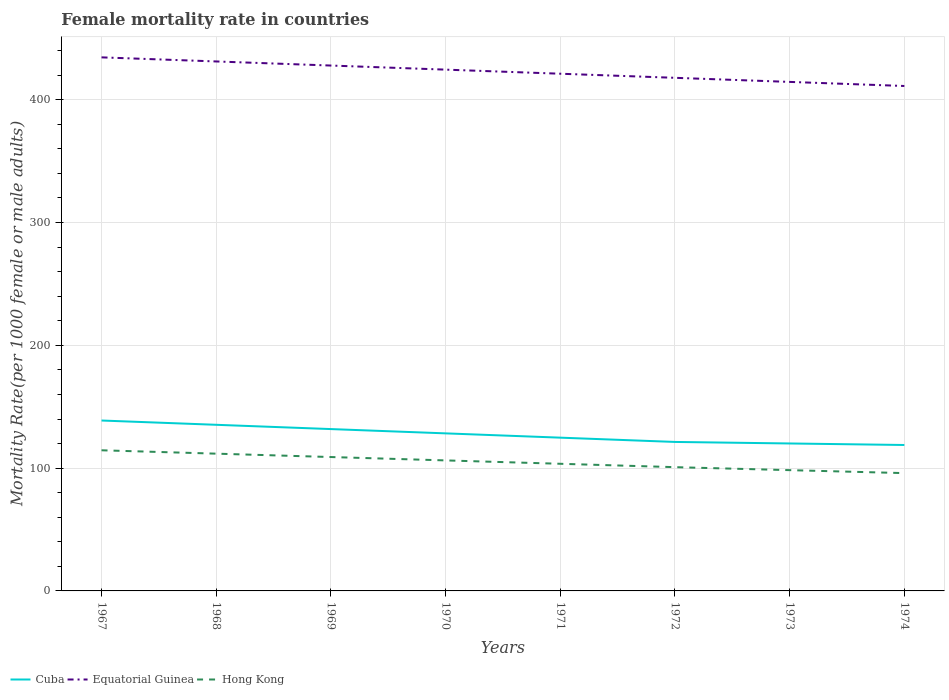Does the line corresponding to Equatorial Guinea intersect with the line corresponding to Hong Kong?
Ensure brevity in your answer.  No. Is the number of lines equal to the number of legend labels?
Provide a short and direct response. Yes. Across all years, what is the maximum female mortality rate in Hong Kong?
Ensure brevity in your answer.  95.92. In which year was the female mortality rate in Cuba maximum?
Ensure brevity in your answer.  1974. What is the total female mortality rate in Cuba in the graph?
Offer a very short reply. 1.24. What is the difference between the highest and the second highest female mortality rate in Hong Kong?
Provide a succinct answer. 18.6. Is the female mortality rate in Cuba strictly greater than the female mortality rate in Equatorial Guinea over the years?
Provide a succinct answer. Yes. How many lines are there?
Offer a very short reply. 3. How many years are there in the graph?
Offer a very short reply. 8. Does the graph contain any zero values?
Your response must be concise. No. Does the graph contain grids?
Make the answer very short. Yes. How many legend labels are there?
Keep it short and to the point. 3. How are the legend labels stacked?
Give a very brief answer. Horizontal. What is the title of the graph?
Give a very brief answer. Female mortality rate in countries. What is the label or title of the X-axis?
Your answer should be very brief. Years. What is the label or title of the Y-axis?
Offer a very short reply. Mortality Rate(per 1000 female or male adults). What is the Mortality Rate(per 1000 female or male adults) in Cuba in 1967?
Keep it short and to the point. 138.77. What is the Mortality Rate(per 1000 female or male adults) of Equatorial Guinea in 1967?
Offer a terse response. 434.49. What is the Mortality Rate(per 1000 female or male adults) of Hong Kong in 1967?
Offer a very short reply. 114.52. What is the Mortality Rate(per 1000 female or male adults) in Cuba in 1968?
Keep it short and to the point. 135.28. What is the Mortality Rate(per 1000 female or male adults) in Equatorial Guinea in 1968?
Make the answer very short. 431.16. What is the Mortality Rate(per 1000 female or male adults) of Hong Kong in 1968?
Offer a very short reply. 111.78. What is the Mortality Rate(per 1000 female or male adults) of Cuba in 1969?
Provide a short and direct response. 131.79. What is the Mortality Rate(per 1000 female or male adults) in Equatorial Guinea in 1969?
Your answer should be compact. 427.83. What is the Mortality Rate(per 1000 female or male adults) of Hong Kong in 1969?
Provide a short and direct response. 109.03. What is the Mortality Rate(per 1000 female or male adults) of Cuba in 1970?
Give a very brief answer. 128.3. What is the Mortality Rate(per 1000 female or male adults) of Equatorial Guinea in 1970?
Your answer should be very brief. 424.5. What is the Mortality Rate(per 1000 female or male adults) in Hong Kong in 1970?
Offer a terse response. 106.28. What is the Mortality Rate(per 1000 female or male adults) in Cuba in 1971?
Keep it short and to the point. 124.81. What is the Mortality Rate(per 1000 female or male adults) of Equatorial Guinea in 1971?
Make the answer very short. 421.17. What is the Mortality Rate(per 1000 female or male adults) of Hong Kong in 1971?
Give a very brief answer. 103.53. What is the Mortality Rate(per 1000 female or male adults) in Cuba in 1972?
Your answer should be very brief. 121.32. What is the Mortality Rate(per 1000 female or male adults) of Equatorial Guinea in 1972?
Keep it short and to the point. 417.84. What is the Mortality Rate(per 1000 female or male adults) in Hong Kong in 1972?
Provide a short and direct response. 100.79. What is the Mortality Rate(per 1000 female or male adults) of Cuba in 1973?
Provide a succinct answer. 120.08. What is the Mortality Rate(per 1000 female or male adults) in Equatorial Guinea in 1973?
Provide a short and direct response. 414.51. What is the Mortality Rate(per 1000 female or male adults) in Hong Kong in 1973?
Your response must be concise. 98.36. What is the Mortality Rate(per 1000 female or male adults) of Cuba in 1974?
Ensure brevity in your answer.  118.83. What is the Mortality Rate(per 1000 female or male adults) in Equatorial Guinea in 1974?
Your answer should be compact. 411.18. What is the Mortality Rate(per 1000 female or male adults) in Hong Kong in 1974?
Keep it short and to the point. 95.92. Across all years, what is the maximum Mortality Rate(per 1000 female or male adults) in Cuba?
Your response must be concise. 138.77. Across all years, what is the maximum Mortality Rate(per 1000 female or male adults) of Equatorial Guinea?
Offer a very short reply. 434.49. Across all years, what is the maximum Mortality Rate(per 1000 female or male adults) of Hong Kong?
Provide a succinct answer. 114.52. Across all years, what is the minimum Mortality Rate(per 1000 female or male adults) of Cuba?
Give a very brief answer. 118.83. Across all years, what is the minimum Mortality Rate(per 1000 female or male adults) in Equatorial Guinea?
Keep it short and to the point. 411.18. Across all years, what is the minimum Mortality Rate(per 1000 female or male adults) in Hong Kong?
Your response must be concise. 95.92. What is the total Mortality Rate(per 1000 female or male adults) of Cuba in the graph?
Keep it short and to the point. 1019.19. What is the total Mortality Rate(per 1000 female or male adults) of Equatorial Guinea in the graph?
Give a very brief answer. 3382.68. What is the total Mortality Rate(per 1000 female or male adults) of Hong Kong in the graph?
Your answer should be very brief. 840.21. What is the difference between the Mortality Rate(per 1000 female or male adults) in Cuba in 1967 and that in 1968?
Your response must be concise. 3.49. What is the difference between the Mortality Rate(per 1000 female or male adults) of Equatorial Guinea in 1967 and that in 1968?
Your answer should be very brief. 3.33. What is the difference between the Mortality Rate(per 1000 female or male adults) in Hong Kong in 1967 and that in 1968?
Offer a very short reply. 2.75. What is the difference between the Mortality Rate(per 1000 female or male adults) in Cuba in 1967 and that in 1969?
Provide a short and direct response. 6.98. What is the difference between the Mortality Rate(per 1000 female or male adults) of Equatorial Guinea in 1967 and that in 1969?
Offer a terse response. 6.66. What is the difference between the Mortality Rate(per 1000 female or male adults) in Hong Kong in 1967 and that in 1969?
Keep it short and to the point. 5.49. What is the difference between the Mortality Rate(per 1000 female or male adults) in Cuba in 1967 and that in 1970?
Ensure brevity in your answer.  10.47. What is the difference between the Mortality Rate(per 1000 female or male adults) in Equatorial Guinea in 1967 and that in 1970?
Your answer should be compact. 9.99. What is the difference between the Mortality Rate(per 1000 female or male adults) in Hong Kong in 1967 and that in 1970?
Make the answer very short. 8.24. What is the difference between the Mortality Rate(per 1000 female or male adults) of Cuba in 1967 and that in 1971?
Offer a terse response. 13.96. What is the difference between the Mortality Rate(per 1000 female or male adults) in Equatorial Guinea in 1967 and that in 1971?
Your answer should be very brief. 13.32. What is the difference between the Mortality Rate(per 1000 female or male adults) of Hong Kong in 1967 and that in 1971?
Your answer should be very brief. 10.99. What is the difference between the Mortality Rate(per 1000 female or male adults) of Cuba in 1967 and that in 1972?
Offer a terse response. 17.45. What is the difference between the Mortality Rate(per 1000 female or male adults) of Equatorial Guinea in 1967 and that in 1972?
Make the answer very short. 16.65. What is the difference between the Mortality Rate(per 1000 female or male adults) of Hong Kong in 1967 and that in 1972?
Ensure brevity in your answer.  13.74. What is the difference between the Mortality Rate(per 1000 female or male adults) of Cuba in 1967 and that in 1973?
Keep it short and to the point. 18.69. What is the difference between the Mortality Rate(per 1000 female or male adults) of Equatorial Guinea in 1967 and that in 1973?
Your answer should be very brief. 19.98. What is the difference between the Mortality Rate(per 1000 female or male adults) in Hong Kong in 1967 and that in 1973?
Ensure brevity in your answer.  16.17. What is the difference between the Mortality Rate(per 1000 female or male adults) of Cuba in 1967 and that in 1974?
Offer a terse response. 19.94. What is the difference between the Mortality Rate(per 1000 female or male adults) in Equatorial Guinea in 1967 and that in 1974?
Your answer should be very brief. 23.31. What is the difference between the Mortality Rate(per 1000 female or male adults) in Hong Kong in 1967 and that in 1974?
Your answer should be compact. 18.6. What is the difference between the Mortality Rate(per 1000 female or male adults) in Cuba in 1968 and that in 1969?
Provide a short and direct response. 3.49. What is the difference between the Mortality Rate(per 1000 female or male adults) in Equatorial Guinea in 1968 and that in 1969?
Keep it short and to the point. 3.33. What is the difference between the Mortality Rate(per 1000 female or male adults) in Hong Kong in 1968 and that in 1969?
Make the answer very short. 2.75. What is the difference between the Mortality Rate(per 1000 female or male adults) of Cuba in 1968 and that in 1970?
Provide a succinct answer. 6.98. What is the difference between the Mortality Rate(per 1000 female or male adults) in Equatorial Guinea in 1968 and that in 1970?
Give a very brief answer. 6.66. What is the difference between the Mortality Rate(per 1000 female or male adults) in Hong Kong in 1968 and that in 1970?
Provide a short and direct response. 5.49. What is the difference between the Mortality Rate(per 1000 female or male adults) in Cuba in 1968 and that in 1971?
Your response must be concise. 10.47. What is the difference between the Mortality Rate(per 1000 female or male adults) of Equatorial Guinea in 1968 and that in 1971?
Keep it short and to the point. 9.99. What is the difference between the Mortality Rate(per 1000 female or male adults) in Hong Kong in 1968 and that in 1971?
Ensure brevity in your answer.  8.24. What is the difference between the Mortality Rate(per 1000 female or male adults) of Cuba in 1968 and that in 1972?
Your response must be concise. 13.96. What is the difference between the Mortality Rate(per 1000 female or male adults) in Equatorial Guinea in 1968 and that in 1972?
Provide a short and direct response. 13.32. What is the difference between the Mortality Rate(per 1000 female or male adults) of Hong Kong in 1968 and that in 1972?
Offer a very short reply. 10.99. What is the difference between the Mortality Rate(per 1000 female or male adults) of Cuba in 1968 and that in 1973?
Give a very brief answer. 15.2. What is the difference between the Mortality Rate(per 1000 female or male adults) in Equatorial Guinea in 1968 and that in 1973?
Your answer should be very brief. 16.65. What is the difference between the Mortality Rate(per 1000 female or male adults) of Hong Kong in 1968 and that in 1973?
Your answer should be very brief. 13.42. What is the difference between the Mortality Rate(per 1000 female or male adults) of Cuba in 1968 and that in 1974?
Provide a succinct answer. 16.45. What is the difference between the Mortality Rate(per 1000 female or male adults) of Equatorial Guinea in 1968 and that in 1974?
Offer a very short reply. 19.98. What is the difference between the Mortality Rate(per 1000 female or male adults) of Hong Kong in 1968 and that in 1974?
Provide a succinct answer. 15.85. What is the difference between the Mortality Rate(per 1000 female or male adults) in Cuba in 1969 and that in 1970?
Ensure brevity in your answer.  3.49. What is the difference between the Mortality Rate(per 1000 female or male adults) of Equatorial Guinea in 1969 and that in 1970?
Provide a succinct answer. 3.33. What is the difference between the Mortality Rate(per 1000 female or male adults) in Hong Kong in 1969 and that in 1970?
Make the answer very short. 2.75. What is the difference between the Mortality Rate(per 1000 female or male adults) of Cuba in 1969 and that in 1971?
Offer a terse response. 6.98. What is the difference between the Mortality Rate(per 1000 female or male adults) in Equatorial Guinea in 1969 and that in 1971?
Your response must be concise. 6.66. What is the difference between the Mortality Rate(per 1000 female or male adults) in Hong Kong in 1969 and that in 1971?
Your response must be concise. 5.49. What is the difference between the Mortality Rate(per 1000 female or male adults) in Cuba in 1969 and that in 1972?
Keep it short and to the point. 10.47. What is the difference between the Mortality Rate(per 1000 female or male adults) of Equatorial Guinea in 1969 and that in 1972?
Provide a short and direct response. 9.99. What is the difference between the Mortality Rate(per 1000 female or male adults) of Hong Kong in 1969 and that in 1972?
Give a very brief answer. 8.24. What is the difference between the Mortality Rate(per 1000 female or male adults) of Cuba in 1969 and that in 1973?
Your response must be concise. 11.71. What is the difference between the Mortality Rate(per 1000 female or male adults) in Equatorial Guinea in 1969 and that in 1973?
Keep it short and to the point. 13.32. What is the difference between the Mortality Rate(per 1000 female or male adults) of Hong Kong in 1969 and that in 1973?
Make the answer very short. 10.67. What is the difference between the Mortality Rate(per 1000 female or male adults) of Cuba in 1969 and that in 1974?
Make the answer very short. 12.96. What is the difference between the Mortality Rate(per 1000 female or male adults) in Equatorial Guinea in 1969 and that in 1974?
Your response must be concise. 16.65. What is the difference between the Mortality Rate(per 1000 female or male adults) of Hong Kong in 1969 and that in 1974?
Provide a short and direct response. 13.1. What is the difference between the Mortality Rate(per 1000 female or male adults) of Cuba in 1970 and that in 1971?
Provide a succinct answer. 3.49. What is the difference between the Mortality Rate(per 1000 female or male adults) of Equatorial Guinea in 1970 and that in 1971?
Your answer should be very brief. 3.33. What is the difference between the Mortality Rate(per 1000 female or male adults) of Hong Kong in 1970 and that in 1971?
Ensure brevity in your answer.  2.75. What is the difference between the Mortality Rate(per 1000 female or male adults) in Cuba in 1970 and that in 1972?
Offer a very short reply. 6.98. What is the difference between the Mortality Rate(per 1000 female or male adults) in Equatorial Guinea in 1970 and that in 1972?
Ensure brevity in your answer.  6.66. What is the difference between the Mortality Rate(per 1000 female or male adults) in Hong Kong in 1970 and that in 1972?
Provide a short and direct response. 5.49. What is the difference between the Mortality Rate(per 1000 female or male adults) in Cuba in 1970 and that in 1973?
Keep it short and to the point. 8.22. What is the difference between the Mortality Rate(per 1000 female or male adults) in Equatorial Guinea in 1970 and that in 1973?
Keep it short and to the point. 9.99. What is the difference between the Mortality Rate(per 1000 female or male adults) in Hong Kong in 1970 and that in 1973?
Your answer should be compact. 7.93. What is the difference between the Mortality Rate(per 1000 female or male adults) in Cuba in 1970 and that in 1974?
Your answer should be compact. 9.47. What is the difference between the Mortality Rate(per 1000 female or male adults) of Equatorial Guinea in 1970 and that in 1974?
Make the answer very short. 13.32. What is the difference between the Mortality Rate(per 1000 female or male adults) in Hong Kong in 1970 and that in 1974?
Keep it short and to the point. 10.36. What is the difference between the Mortality Rate(per 1000 female or male adults) in Cuba in 1971 and that in 1972?
Offer a terse response. 3.49. What is the difference between the Mortality Rate(per 1000 female or male adults) of Equatorial Guinea in 1971 and that in 1972?
Keep it short and to the point. 3.33. What is the difference between the Mortality Rate(per 1000 female or male adults) of Hong Kong in 1971 and that in 1972?
Ensure brevity in your answer.  2.75. What is the difference between the Mortality Rate(per 1000 female or male adults) in Cuba in 1971 and that in 1973?
Make the answer very short. 4.73. What is the difference between the Mortality Rate(per 1000 female or male adults) of Equatorial Guinea in 1971 and that in 1973?
Offer a terse response. 6.66. What is the difference between the Mortality Rate(per 1000 female or male adults) in Hong Kong in 1971 and that in 1973?
Provide a succinct answer. 5.18. What is the difference between the Mortality Rate(per 1000 female or male adults) in Cuba in 1971 and that in 1974?
Ensure brevity in your answer.  5.98. What is the difference between the Mortality Rate(per 1000 female or male adults) of Equatorial Guinea in 1971 and that in 1974?
Offer a terse response. 9.99. What is the difference between the Mortality Rate(per 1000 female or male adults) in Hong Kong in 1971 and that in 1974?
Provide a succinct answer. 7.61. What is the difference between the Mortality Rate(per 1000 female or male adults) in Cuba in 1972 and that in 1973?
Provide a short and direct response. 1.24. What is the difference between the Mortality Rate(per 1000 female or male adults) of Equatorial Guinea in 1972 and that in 1973?
Provide a short and direct response. 3.33. What is the difference between the Mortality Rate(per 1000 female or male adults) of Hong Kong in 1972 and that in 1973?
Offer a very short reply. 2.43. What is the difference between the Mortality Rate(per 1000 female or male adults) of Cuba in 1972 and that in 1974?
Keep it short and to the point. 2.49. What is the difference between the Mortality Rate(per 1000 female or male adults) in Equatorial Guinea in 1972 and that in 1974?
Offer a terse response. 6.66. What is the difference between the Mortality Rate(per 1000 female or male adults) of Hong Kong in 1972 and that in 1974?
Make the answer very short. 4.86. What is the difference between the Mortality Rate(per 1000 female or male adults) in Cuba in 1973 and that in 1974?
Your answer should be very brief. 1.24. What is the difference between the Mortality Rate(per 1000 female or male adults) of Equatorial Guinea in 1973 and that in 1974?
Ensure brevity in your answer.  3.33. What is the difference between the Mortality Rate(per 1000 female or male adults) in Hong Kong in 1973 and that in 1974?
Ensure brevity in your answer.  2.43. What is the difference between the Mortality Rate(per 1000 female or male adults) in Cuba in 1967 and the Mortality Rate(per 1000 female or male adults) in Equatorial Guinea in 1968?
Offer a terse response. -292.39. What is the difference between the Mortality Rate(per 1000 female or male adults) of Cuba in 1967 and the Mortality Rate(per 1000 female or male adults) of Hong Kong in 1968?
Ensure brevity in your answer.  26.99. What is the difference between the Mortality Rate(per 1000 female or male adults) in Equatorial Guinea in 1967 and the Mortality Rate(per 1000 female or male adults) in Hong Kong in 1968?
Ensure brevity in your answer.  322.72. What is the difference between the Mortality Rate(per 1000 female or male adults) in Cuba in 1967 and the Mortality Rate(per 1000 female or male adults) in Equatorial Guinea in 1969?
Provide a short and direct response. -289.06. What is the difference between the Mortality Rate(per 1000 female or male adults) of Cuba in 1967 and the Mortality Rate(per 1000 female or male adults) of Hong Kong in 1969?
Ensure brevity in your answer.  29.74. What is the difference between the Mortality Rate(per 1000 female or male adults) in Equatorial Guinea in 1967 and the Mortality Rate(per 1000 female or male adults) in Hong Kong in 1969?
Your answer should be very brief. 325.46. What is the difference between the Mortality Rate(per 1000 female or male adults) of Cuba in 1967 and the Mortality Rate(per 1000 female or male adults) of Equatorial Guinea in 1970?
Ensure brevity in your answer.  -285.73. What is the difference between the Mortality Rate(per 1000 female or male adults) in Cuba in 1967 and the Mortality Rate(per 1000 female or male adults) in Hong Kong in 1970?
Offer a terse response. 32.49. What is the difference between the Mortality Rate(per 1000 female or male adults) in Equatorial Guinea in 1967 and the Mortality Rate(per 1000 female or male adults) in Hong Kong in 1970?
Offer a terse response. 328.21. What is the difference between the Mortality Rate(per 1000 female or male adults) of Cuba in 1967 and the Mortality Rate(per 1000 female or male adults) of Equatorial Guinea in 1971?
Your answer should be compact. -282.4. What is the difference between the Mortality Rate(per 1000 female or male adults) in Cuba in 1967 and the Mortality Rate(per 1000 female or male adults) in Hong Kong in 1971?
Give a very brief answer. 35.24. What is the difference between the Mortality Rate(per 1000 female or male adults) of Equatorial Guinea in 1967 and the Mortality Rate(per 1000 female or male adults) of Hong Kong in 1971?
Provide a short and direct response. 330.96. What is the difference between the Mortality Rate(per 1000 female or male adults) of Cuba in 1967 and the Mortality Rate(per 1000 female or male adults) of Equatorial Guinea in 1972?
Provide a short and direct response. -279.07. What is the difference between the Mortality Rate(per 1000 female or male adults) in Cuba in 1967 and the Mortality Rate(per 1000 female or male adults) in Hong Kong in 1972?
Your answer should be compact. 37.98. What is the difference between the Mortality Rate(per 1000 female or male adults) of Equatorial Guinea in 1967 and the Mortality Rate(per 1000 female or male adults) of Hong Kong in 1972?
Keep it short and to the point. 333.7. What is the difference between the Mortality Rate(per 1000 female or male adults) of Cuba in 1967 and the Mortality Rate(per 1000 female or male adults) of Equatorial Guinea in 1973?
Offer a very short reply. -275.74. What is the difference between the Mortality Rate(per 1000 female or male adults) of Cuba in 1967 and the Mortality Rate(per 1000 female or male adults) of Hong Kong in 1973?
Your answer should be compact. 40.41. What is the difference between the Mortality Rate(per 1000 female or male adults) in Equatorial Guinea in 1967 and the Mortality Rate(per 1000 female or male adults) in Hong Kong in 1973?
Offer a terse response. 336.13. What is the difference between the Mortality Rate(per 1000 female or male adults) of Cuba in 1967 and the Mortality Rate(per 1000 female or male adults) of Equatorial Guinea in 1974?
Offer a very short reply. -272.41. What is the difference between the Mortality Rate(per 1000 female or male adults) of Cuba in 1967 and the Mortality Rate(per 1000 female or male adults) of Hong Kong in 1974?
Your response must be concise. 42.84. What is the difference between the Mortality Rate(per 1000 female or male adults) in Equatorial Guinea in 1967 and the Mortality Rate(per 1000 female or male adults) in Hong Kong in 1974?
Your answer should be very brief. 338.57. What is the difference between the Mortality Rate(per 1000 female or male adults) in Cuba in 1968 and the Mortality Rate(per 1000 female or male adults) in Equatorial Guinea in 1969?
Provide a succinct answer. -292.55. What is the difference between the Mortality Rate(per 1000 female or male adults) of Cuba in 1968 and the Mortality Rate(per 1000 female or male adults) of Hong Kong in 1969?
Your answer should be compact. 26.25. What is the difference between the Mortality Rate(per 1000 female or male adults) of Equatorial Guinea in 1968 and the Mortality Rate(per 1000 female or male adults) of Hong Kong in 1969?
Provide a succinct answer. 322.13. What is the difference between the Mortality Rate(per 1000 female or male adults) in Cuba in 1968 and the Mortality Rate(per 1000 female or male adults) in Equatorial Guinea in 1970?
Your answer should be very brief. -289.22. What is the difference between the Mortality Rate(per 1000 female or male adults) of Cuba in 1968 and the Mortality Rate(per 1000 female or male adults) of Hong Kong in 1970?
Offer a very short reply. 29. What is the difference between the Mortality Rate(per 1000 female or male adults) of Equatorial Guinea in 1968 and the Mortality Rate(per 1000 female or male adults) of Hong Kong in 1970?
Keep it short and to the point. 324.88. What is the difference between the Mortality Rate(per 1000 female or male adults) of Cuba in 1968 and the Mortality Rate(per 1000 female or male adults) of Equatorial Guinea in 1971?
Your answer should be very brief. -285.89. What is the difference between the Mortality Rate(per 1000 female or male adults) of Cuba in 1968 and the Mortality Rate(per 1000 female or male adults) of Hong Kong in 1971?
Your answer should be compact. 31.75. What is the difference between the Mortality Rate(per 1000 female or male adults) in Equatorial Guinea in 1968 and the Mortality Rate(per 1000 female or male adults) in Hong Kong in 1971?
Offer a very short reply. 327.63. What is the difference between the Mortality Rate(per 1000 female or male adults) of Cuba in 1968 and the Mortality Rate(per 1000 female or male adults) of Equatorial Guinea in 1972?
Make the answer very short. -282.56. What is the difference between the Mortality Rate(per 1000 female or male adults) in Cuba in 1968 and the Mortality Rate(per 1000 female or male adults) in Hong Kong in 1972?
Give a very brief answer. 34.49. What is the difference between the Mortality Rate(per 1000 female or male adults) in Equatorial Guinea in 1968 and the Mortality Rate(per 1000 female or male adults) in Hong Kong in 1972?
Your response must be concise. 330.37. What is the difference between the Mortality Rate(per 1000 female or male adults) in Cuba in 1968 and the Mortality Rate(per 1000 female or male adults) in Equatorial Guinea in 1973?
Offer a terse response. -279.23. What is the difference between the Mortality Rate(per 1000 female or male adults) of Cuba in 1968 and the Mortality Rate(per 1000 female or male adults) of Hong Kong in 1973?
Your answer should be very brief. 36.92. What is the difference between the Mortality Rate(per 1000 female or male adults) in Equatorial Guinea in 1968 and the Mortality Rate(per 1000 female or male adults) in Hong Kong in 1973?
Keep it short and to the point. 332.8. What is the difference between the Mortality Rate(per 1000 female or male adults) in Cuba in 1968 and the Mortality Rate(per 1000 female or male adults) in Equatorial Guinea in 1974?
Make the answer very short. -275.9. What is the difference between the Mortality Rate(per 1000 female or male adults) in Cuba in 1968 and the Mortality Rate(per 1000 female or male adults) in Hong Kong in 1974?
Ensure brevity in your answer.  39.36. What is the difference between the Mortality Rate(per 1000 female or male adults) of Equatorial Guinea in 1968 and the Mortality Rate(per 1000 female or male adults) of Hong Kong in 1974?
Give a very brief answer. 335.24. What is the difference between the Mortality Rate(per 1000 female or male adults) of Cuba in 1969 and the Mortality Rate(per 1000 female or male adults) of Equatorial Guinea in 1970?
Offer a terse response. -292.71. What is the difference between the Mortality Rate(per 1000 female or male adults) in Cuba in 1969 and the Mortality Rate(per 1000 female or male adults) in Hong Kong in 1970?
Your answer should be very brief. 25.51. What is the difference between the Mortality Rate(per 1000 female or male adults) of Equatorial Guinea in 1969 and the Mortality Rate(per 1000 female or male adults) of Hong Kong in 1970?
Offer a very short reply. 321.55. What is the difference between the Mortality Rate(per 1000 female or male adults) in Cuba in 1969 and the Mortality Rate(per 1000 female or male adults) in Equatorial Guinea in 1971?
Keep it short and to the point. -289.38. What is the difference between the Mortality Rate(per 1000 female or male adults) in Cuba in 1969 and the Mortality Rate(per 1000 female or male adults) in Hong Kong in 1971?
Offer a terse response. 28.26. What is the difference between the Mortality Rate(per 1000 female or male adults) of Equatorial Guinea in 1969 and the Mortality Rate(per 1000 female or male adults) of Hong Kong in 1971?
Make the answer very short. 324.3. What is the difference between the Mortality Rate(per 1000 female or male adults) of Cuba in 1969 and the Mortality Rate(per 1000 female or male adults) of Equatorial Guinea in 1972?
Provide a succinct answer. -286.05. What is the difference between the Mortality Rate(per 1000 female or male adults) in Cuba in 1969 and the Mortality Rate(per 1000 female or male adults) in Hong Kong in 1972?
Your response must be concise. 31. What is the difference between the Mortality Rate(per 1000 female or male adults) in Equatorial Guinea in 1969 and the Mortality Rate(per 1000 female or male adults) in Hong Kong in 1972?
Your answer should be very brief. 327.04. What is the difference between the Mortality Rate(per 1000 female or male adults) of Cuba in 1969 and the Mortality Rate(per 1000 female or male adults) of Equatorial Guinea in 1973?
Make the answer very short. -282.72. What is the difference between the Mortality Rate(per 1000 female or male adults) in Cuba in 1969 and the Mortality Rate(per 1000 female or male adults) in Hong Kong in 1973?
Ensure brevity in your answer.  33.44. What is the difference between the Mortality Rate(per 1000 female or male adults) in Equatorial Guinea in 1969 and the Mortality Rate(per 1000 female or male adults) in Hong Kong in 1973?
Give a very brief answer. 329.47. What is the difference between the Mortality Rate(per 1000 female or male adults) in Cuba in 1969 and the Mortality Rate(per 1000 female or male adults) in Equatorial Guinea in 1974?
Keep it short and to the point. -279.39. What is the difference between the Mortality Rate(per 1000 female or male adults) in Cuba in 1969 and the Mortality Rate(per 1000 female or male adults) in Hong Kong in 1974?
Keep it short and to the point. 35.87. What is the difference between the Mortality Rate(per 1000 female or male adults) of Equatorial Guinea in 1969 and the Mortality Rate(per 1000 female or male adults) of Hong Kong in 1974?
Provide a short and direct response. 331.9. What is the difference between the Mortality Rate(per 1000 female or male adults) of Cuba in 1970 and the Mortality Rate(per 1000 female or male adults) of Equatorial Guinea in 1971?
Offer a terse response. -292.87. What is the difference between the Mortality Rate(per 1000 female or male adults) in Cuba in 1970 and the Mortality Rate(per 1000 female or male adults) in Hong Kong in 1971?
Your answer should be compact. 24.77. What is the difference between the Mortality Rate(per 1000 female or male adults) of Equatorial Guinea in 1970 and the Mortality Rate(per 1000 female or male adults) of Hong Kong in 1971?
Keep it short and to the point. 320.96. What is the difference between the Mortality Rate(per 1000 female or male adults) in Cuba in 1970 and the Mortality Rate(per 1000 female or male adults) in Equatorial Guinea in 1972?
Your response must be concise. -289.54. What is the difference between the Mortality Rate(per 1000 female or male adults) in Cuba in 1970 and the Mortality Rate(per 1000 female or male adults) in Hong Kong in 1972?
Your answer should be very brief. 27.51. What is the difference between the Mortality Rate(per 1000 female or male adults) of Equatorial Guinea in 1970 and the Mortality Rate(per 1000 female or male adults) of Hong Kong in 1972?
Provide a succinct answer. 323.71. What is the difference between the Mortality Rate(per 1000 female or male adults) of Cuba in 1970 and the Mortality Rate(per 1000 female or male adults) of Equatorial Guinea in 1973?
Ensure brevity in your answer.  -286.21. What is the difference between the Mortality Rate(per 1000 female or male adults) in Cuba in 1970 and the Mortality Rate(per 1000 female or male adults) in Hong Kong in 1973?
Make the answer very short. 29.95. What is the difference between the Mortality Rate(per 1000 female or male adults) in Equatorial Guinea in 1970 and the Mortality Rate(per 1000 female or male adults) in Hong Kong in 1973?
Keep it short and to the point. 326.14. What is the difference between the Mortality Rate(per 1000 female or male adults) of Cuba in 1970 and the Mortality Rate(per 1000 female or male adults) of Equatorial Guinea in 1974?
Your answer should be very brief. -282.88. What is the difference between the Mortality Rate(per 1000 female or male adults) in Cuba in 1970 and the Mortality Rate(per 1000 female or male adults) in Hong Kong in 1974?
Your answer should be very brief. 32.38. What is the difference between the Mortality Rate(per 1000 female or male adults) of Equatorial Guinea in 1970 and the Mortality Rate(per 1000 female or male adults) of Hong Kong in 1974?
Make the answer very short. 328.57. What is the difference between the Mortality Rate(per 1000 female or male adults) in Cuba in 1971 and the Mortality Rate(per 1000 female or male adults) in Equatorial Guinea in 1972?
Offer a very short reply. -293.03. What is the difference between the Mortality Rate(per 1000 female or male adults) in Cuba in 1971 and the Mortality Rate(per 1000 female or male adults) in Hong Kong in 1972?
Provide a succinct answer. 24.02. What is the difference between the Mortality Rate(per 1000 female or male adults) in Equatorial Guinea in 1971 and the Mortality Rate(per 1000 female or male adults) in Hong Kong in 1972?
Keep it short and to the point. 320.38. What is the difference between the Mortality Rate(per 1000 female or male adults) of Cuba in 1971 and the Mortality Rate(per 1000 female or male adults) of Equatorial Guinea in 1973?
Your response must be concise. -289.7. What is the difference between the Mortality Rate(per 1000 female or male adults) in Cuba in 1971 and the Mortality Rate(per 1000 female or male adults) in Hong Kong in 1973?
Your response must be concise. 26.45. What is the difference between the Mortality Rate(per 1000 female or male adults) of Equatorial Guinea in 1971 and the Mortality Rate(per 1000 female or male adults) of Hong Kong in 1973?
Make the answer very short. 322.81. What is the difference between the Mortality Rate(per 1000 female or male adults) in Cuba in 1971 and the Mortality Rate(per 1000 female or male adults) in Equatorial Guinea in 1974?
Your answer should be compact. -286.37. What is the difference between the Mortality Rate(per 1000 female or male adults) in Cuba in 1971 and the Mortality Rate(per 1000 female or male adults) in Hong Kong in 1974?
Offer a very short reply. 28.89. What is the difference between the Mortality Rate(per 1000 female or male adults) in Equatorial Guinea in 1971 and the Mortality Rate(per 1000 female or male adults) in Hong Kong in 1974?
Make the answer very short. 325.24. What is the difference between the Mortality Rate(per 1000 female or male adults) in Cuba in 1972 and the Mortality Rate(per 1000 female or male adults) in Equatorial Guinea in 1973?
Your answer should be compact. -293.19. What is the difference between the Mortality Rate(per 1000 female or male adults) of Cuba in 1972 and the Mortality Rate(per 1000 female or male adults) of Hong Kong in 1973?
Make the answer very short. 22.96. What is the difference between the Mortality Rate(per 1000 female or male adults) in Equatorial Guinea in 1972 and the Mortality Rate(per 1000 female or male adults) in Hong Kong in 1973?
Offer a terse response. 319.48. What is the difference between the Mortality Rate(per 1000 female or male adults) in Cuba in 1972 and the Mortality Rate(per 1000 female or male adults) in Equatorial Guinea in 1974?
Offer a very short reply. -289.86. What is the difference between the Mortality Rate(per 1000 female or male adults) of Cuba in 1972 and the Mortality Rate(per 1000 female or male adults) of Hong Kong in 1974?
Keep it short and to the point. 25.4. What is the difference between the Mortality Rate(per 1000 female or male adults) in Equatorial Guinea in 1972 and the Mortality Rate(per 1000 female or male adults) in Hong Kong in 1974?
Your response must be concise. 321.91. What is the difference between the Mortality Rate(per 1000 female or male adults) of Cuba in 1973 and the Mortality Rate(per 1000 female or male adults) of Equatorial Guinea in 1974?
Keep it short and to the point. -291.1. What is the difference between the Mortality Rate(per 1000 female or male adults) in Cuba in 1973 and the Mortality Rate(per 1000 female or male adults) in Hong Kong in 1974?
Your answer should be compact. 24.15. What is the difference between the Mortality Rate(per 1000 female or male adults) in Equatorial Guinea in 1973 and the Mortality Rate(per 1000 female or male adults) in Hong Kong in 1974?
Provide a short and direct response. 318.58. What is the average Mortality Rate(per 1000 female or male adults) of Cuba per year?
Offer a terse response. 127.4. What is the average Mortality Rate(per 1000 female or male adults) of Equatorial Guinea per year?
Ensure brevity in your answer.  422.83. What is the average Mortality Rate(per 1000 female or male adults) of Hong Kong per year?
Your response must be concise. 105.03. In the year 1967, what is the difference between the Mortality Rate(per 1000 female or male adults) of Cuba and Mortality Rate(per 1000 female or male adults) of Equatorial Guinea?
Ensure brevity in your answer.  -295.72. In the year 1967, what is the difference between the Mortality Rate(per 1000 female or male adults) of Cuba and Mortality Rate(per 1000 female or male adults) of Hong Kong?
Offer a terse response. 24.25. In the year 1967, what is the difference between the Mortality Rate(per 1000 female or male adults) in Equatorial Guinea and Mortality Rate(per 1000 female or male adults) in Hong Kong?
Ensure brevity in your answer.  319.97. In the year 1968, what is the difference between the Mortality Rate(per 1000 female or male adults) in Cuba and Mortality Rate(per 1000 female or male adults) in Equatorial Guinea?
Provide a succinct answer. -295.88. In the year 1968, what is the difference between the Mortality Rate(per 1000 female or male adults) in Cuba and Mortality Rate(per 1000 female or male adults) in Hong Kong?
Make the answer very short. 23.51. In the year 1968, what is the difference between the Mortality Rate(per 1000 female or male adults) of Equatorial Guinea and Mortality Rate(per 1000 female or male adults) of Hong Kong?
Ensure brevity in your answer.  319.38. In the year 1969, what is the difference between the Mortality Rate(per 1000 female or male adults) of Cuba and Mortality Rate(per 1000 female or male adults) of Equatorial Guinea?
Your answer should be compact. -296.04. In the year 1969, what is the difference between the Mortality Rate(per 1000 female or male adults) in Cuba and Mortality Rate(per 1000 female or male adults) in Hong Kong?
Your answer should be compact. 22.76. In the year 1969, what is the difference between the Mortality Rate(per 1000 female or male adults) in Equatorial Guinea and Mortality Rate(per 1000 female or male adults) in Hong Kong?
Give a very brief answer. 318.8. In the year 1970, what is the difference between the Mortality Rate(per 1000 female or male adults) in Cuba and Mortality Rate(per 1000 female or male adults) in Equatorial Guinea?
Make the answer very short. -296.2. In the year 1970, what is the difference between the Mortality Rate(per 1000 female or male adults) of Cuba and Mortality Rate(per 1000 female or male adults) of Hong Kong?
Keep it short and to the point. 22.02. In the year 1970, what is the difference between the Mortality Rate(per 1000 female or male adults) of Equatorial Guinea and Mortality Rate(per 1000 female or male adults) of Hong Kong?
Your answer should be very brief. 318.22. In the year 1971, what is the difference between the Mortality Rate(per 1000 female or male adults) in Cuba and Mortality Rate(per 1000 female or male adults) in Equatorial Guinea?
Provide a short and direct response. -296.36. In the year 1971, what is the difference between the Mortality Rate(per 1000 female or male adults) in Cuba and Mortality Rate(per 1000 female or male adults) in Hong Kong?
Your answer should be compact. 21.28. In the year 1971, what is the difference between the Mortality Rate(per 1000 female or male adults) in Equatorial Guinea and Mortality Rate(per 1000 female or male adults) in Hong Kong?
Offer a very short reply. 317.63. In the year 1972, what is the difference between the Mortality Rate(per 1000 female or male adults) in Cuba and Mortality Rate(per 1000 female or male adults) in Equatorial Guinea?
Make the answer very short. -296.52. In the year 1972, what is the difference between the Mortality Rate(per 1000 female or male adults) of Cuba and Mortality Rate(per 1000 female or male adults) of Hong Kong?
Offer a terse response. 20.53. In the year 1972, what is the difference between the Mortality Rate(per 1000 female or male adults) in Equatorial Guinea and Mortality Rate(per 1000 female or male adults) in Hong Kong?
Ensure brevity in your answer.  317.05. In the year 1973, what is the difference between the Mortality Rate(per 1000 female or male adults) of Cuba and Mortality Rate(per 1000 female or male adults) of Equatorial Guinea?
Make the answer very short. -294.43. In the year 1973, what is the difference between the Mortality Rate(per 1000 female or male adults) of Cuba and Mortality Rate(per 1000 female or male adults) of Hong Kong?
Your answer should be very brief. 21.72. In the year 1973, what is the difference between the Mortality Rate(per 1000 female or male adults) of Equatorial Guinea and Mortality Rate(per 1000 female or male adults) of Hong Kong?
Your response must be concise. 316.15. In the year 1974, what is the difference between the Mortality Rate(per 1000 female or male adults) of Cuba and Mortality Rate(per 1000 female or male adults) of Equatorial Guinea?
Offer a very short reply. -292.35. In the year 1974, what is the difference between the Mortality Rate(per 1000 female or male adults) in Cuba and Mortality Rate(per 1000 female or male adults) in Hong Kong?
Ensure brevity in your answer.  22.91. In the year 1974, what is the difference between the Mortality Rate(per 1000 female or male adults) in Equatorial Guinea and Mortality Rate(per 1000 female or male adults) in Hong Kong?
Keep it short and to the point. 315.26. What is the ratio of the Mortality Rate(per 1000 female or male adults) in Cuba in 1967 to that in 1968?
Ensure brevity in your answer.  1.03. What is the ratio of the Mortality Rate(per 1000 female or male adults) of Equatorial Guinea in 1967 to that in 1968?
Give a very brief answer. 1.01. What is the ratio of the Mortality Rate(per 1000 female or male adults) in Hong Kong in 1967 to that in 1968?
Provide a short and direct response. 1.02. What is the ratio of the Mortality Rate(per 1000 female or male adults) of Cuba in 1967 to that in 1969?
Provide a succinct answer. 1.05. What is the ratio of the Mortality Rate(per 1000 female or male adults) in Equatorial Guinea in 1967 to that in 1969?
Provide a short and direct response. 1.02. What is the ratio of the Mortality Rate(per 1000 female or male adults) in Hong Kong in 1967 to that in 1969?
Ensure brevity in your answer.  1.05. What is the ratio of the Mortality Rate(per 1000 female or male adults) of Cuba in 1967 to that in 1970?
Keep it short and to the point. 1.08. What is the ratio of the Mortality Rate(per 1000 female or male adults) of Equatorial Guinea in 1967 to that in 1970?
Offer a very short reply. 1.02. What is the ratio of the Mortality Rate(per 1000 female or male adults) of Hong Kong in 1967 to that in 1970?
Your response must be concise. 1.08. What is the ratio of the Mortality Rate(per 1000 female or male adults) in Cuba in 1967 to that in 1971?
Your response must be concise. 1.11. What is the ratio of the Mortality Rate(per 1000 female or male adults) in Equatorial Guinea in 1967 to that in 1971?
Offer a terse response. 1.03. What is the ratio of the Mortality Rate(per 1000 female or male adults) of Hong Kong in 1967 to that in 1971?
Provide a succinct answer. 1.11. What is the ratio of the Mortality Rate(per 1000 female or male adults) of Cuba in 1967 to that in 1972?
Provide a succinct answer. 1.14. What is the ratio of the Mortality Rate(per 1000 female or male adults) of Equatorial Guinea in 1967 to that in 1972?
Ensure brevity in your answer.  1.04. What is the ratio of the Mortality Rate(per 1000 female or male adults) of Hong Kong in 1967 to that in 1972?
Ensure brevity in your answer.  1.14. What is the ratio of the Mortality Rate(per 1000 female or male adults) in Cuba in 1967 to that in 1973?
Give a very brief answer. 1.16. What is the ratio of the Mortality Rate(per 1000 female or male adults) of Equatorial Guinea in 1967 to that in 1973?
Ensure brevity in your answer.  1.05. What is the ratio of the Mortality Rate(per 1000 female or male adults) in Hong Kong in 1967 to that in 1973?
Keep it short and to the point. 1.16. What is the ratio of the Mortality Rate(per 1000 female or male adults) in Cuba in 1967 to that in 1974?
Keep it short and to the point. 1.17. What is the ratio of the Mortality Rate(per 1000 female or male adults) in Equatorial Guinea in 1967 to that in 1974?
Offer a very short reply. 1.06. What is the ratio of the Mortality Rate(per 1000 female or male adults) in Hong Kong in 1967 to that in 1974?
Keep it short and to the point. 1.19. What is the ratio of the Mortality Rate(per 1000 female or male adults) of Cuba in 1968 to that in 1969?
Keep it short and to the point. 1.03. What is the ratio of the Mortality Rate(per 1000 female or male adults) in Hong Kong in 1968 to that in 1969?
Ensure brevity in your answer.  1.03. What is the ratio of the Mortality Rate(per 1000 female or male adults) of Cuba in 1968 to that in 1970?
Keep it short and to the point. 1.05. What is the ratio of the Mortality Rate(per 1000 female or male adults) in Equatorial Guinea in 1968 to that in 1970?
Provide a succinct answer. 1.02. What is the ratio of the Mortality Rate(per 1000 female or male adults) in Hong Kong in 1968 to that in 1970?
Offer a terse response. 1.05. What is the ratio of the Mortality Rate(per 1000 female or male adults) in Cuba in 1968 to that in 1971?
Your answer should be compact. 1.08. What is the ratio of the Mortality Rate(per 1000 female or male adults) of Equatorial Guinea in 1968 to that in 1971?
Provide a short and direct response. 1.02. What is the ratio of the Mortality Rate(per 1000 female or male adults) of Hong Kong in 1968 to that in 1971?
Offer a very short reply. 1.08. What is the ratio of the Mortality Rate(per 1000 female or male adults) of Cuba in 1968 to that in 1972?
Your response must be concise. 1.12. What is the ratio of the Mortality Rate(per 1000 female or male adults) in Equatorial Guinea in 1968 to that in 1972?
Provide a succinct answer. 1.03. What is the ratio of the Mortality Rate(per 1000 female or male adults) of Hong Kong in 1968 to that in 1972?
Give a very brief answer. 1.11. What is the ratio of the Mortality Rate(per 1000 female or male adults) in Cuba in 1968 to that in 1973?
Make the answer very short. 1.13. What is the ratio of the Mortality Rate(per 1000 female or male adults) in Equatorial Guinea in 1968 to that in 1973?
Your response must be concise. 1.04. What is the ratio of the Mortality Rate(per 1000 female or male adults) of Hong Kong in 1968 to that in 1973?
Keep it short and to the point. 1.14. What is the ratio of the Mortality Rate(per 1000 female or male adults) in Cuba in 1968 to that in 1974?
Make the answer very short. 1.14. What is the ratio of the Mortality Rate(per 1000 female or male adults) in Equatorial Guinea in 1968 to that in 1974?
Make the answer very short. 1.05. What is the ratio of the Mortality Rate(per 1000 female or male adults) in Hong Kong in 1968 to that in 1974?
Offer a very short reply. 1.17. What is the ratio of the Mortality Rate(per 1000 female or male adults) of Cuba in 1969 to that in 1970?
Provide a succinct answer. 1.03. What is the ratio of the Mortality Rate(per 1000 female or male adults) of Equatorial Guinea in 1969 to that in 1970?
Your answer should be compact. 1.01. What is the ratio of the Mortality Rate(per 1000 female or male adults) in Hong Kong in 1969 to that in 1970?
Your answer should be compact. 1.03. What is the ratio of the Mortality Rate(per 1000 female or male adults) of Cuba in 1969 to that in 1971?
Your answer should be very brief. 1.06. What is the ratio of the Mortality Rate(per 1000 female or male adults) of Equatorial Guinea in 1969 to that in 1971?
Provide a succinct answer. 1.02. What is the ratio of the Mortality Rate(per 1000 female or male adults) in Hong Kong in 1969 to that in 1971?
Ensure brevity in your answer.  1.05. What is the ratio of the Mortality Rate(per 1000 female or male adults) in Cuba in 1969 to that in 1972?
Give a very brief answer. 1.09. What is the ratio of the Mortality Rate(per 1000 female or male adults) in Equatorial Guinea in 1969 to that in 1972?
Your response must be concise. 1.02. What is the ratio of the Mortality Rate(per 1000 female or male adults) in Hong Kong in 1969 to that in 1972?
Provide a succinct answer. 1.08. What is the ratio of the Mortality Rate(per 1000 female or male adults) of Cuba in 1969 to that in 1973?
Provide a short and direct response. 1.1. What is the ratio of the Mortality Rate(per 1000 female or male adults) of Equatorial Guinea in 1969 to that in 1973?
Your answer should be compact. 1.03. What is the ratio of the Mortality Rate(per 1000 female or male adults) of Hong Kong in 1969 to that in 1973?
Your answer should be compact. 1.11. What is the ratio of the Mortality Rate(per 1000 female or male adults) of Cuba in 1969 to that in 1974?
Offer a terse response. 1.11. What is the ratio of the Mortality Rate(per 1000 female or male adults) of Equatorial Guinea in 1969 to that in 1974?
Offer a terse response. 1.04. What is the ratio of the Mortality Rate(per 1000 female or male adults) in Hong Kong in 1969 to that in 1974?
Provide a short and direct response. 1.14. What is the ratio of the Mortality Rate(per 1000 female or male adults) in Cuba in 1970 to that in 1971?
Ensure brevity in your answer.  1.03. What is the ratio of the Mortality Rate(per 1000 female or male adults) of Equatorial Guinea in 1970 to that in 1971?
Your answer should be very brief. 1.01. What is the ratio of the Mortality Rate(per 1000 female or male adults) of Hong Kong in 1970 to that in 1971?
Keep it short and to the point. 1.03. What is the ratio of the Mortality Rate(per 1000 female or male adults) of Cuba in 1970 to that in 1972?
Provide a succinct answer. 1.06. What is the ratio of the Mortality Rate(per 1000 female or male adults) of Equatorial Guinea in 1970 to that in 1972?
Keep it short and to the point. 1.02. What is the ratio of the Mortality Rate(per 1000 female or male adults) of Hong Kong in 1970 to that in 1972?
Ensure brevity in your answer.  1.05. What is the ratio of the Mortality Rate(per 1000 female or male adults) of Cuba in 1970 to that in 1973?
Offer a very short reply. 1.07. What is the ratio of the Mortality Rate(per 1000 female or male adults) in Equatorial Guinea in 1970 to that in 1973?
Ensure brevity in your answer.  1.02. What is the ratio of the Mortality Rate(per 1000 female or male adults) in Hong Kong in 1970 to that in 1973?
Your answer should be very brief. 1.08. What is the ratio of the Mortality Rate(per 1000 female or male adults) in Cuba in 1970 to that in 1974?
Give a very brief answer. 1.08. What is the ratio of the Mortality Rate(per 1000 female or male adults) in Equatorial Guinea in 1970 to that in 1974?
Your answer should be very brief. 1.03. What is the ratio of the Mortality Rate(per 1000 female or male adults) in Hong Kong in 1970 to that in 1974?
Provide a short and direct response. 1.11. What is the ratio of the Mortality Rate(per 1000 female or male adults) in Cuba in 1971 to that in 1972?
Your answer should be very brief. 1.03. What is the ratio of the Mortality Rate(per 1000 female or male adults) of Equatorial Guinea in 1971 to that in 1972?
Your response must be concise. 1.01. What is the ratio of the Mortality Rate(per 1000 female or male adults) of Hong Kong in 1971 to that in 1972?
Provide a short and direct response. 1.03. What is the ratio of the Mortality Rate(per 1000 female or male adults) in Cuba in 1971 to that in 1973?
Ensure brevity in your answer.  1.04. What is the ratio of the Mortality Rate(per 1000 female or male adults) of Equatorial Guinea in 1971 to that in 1973?
Your answer should be very brief. 1.02. What is the ratio of the Mortality Rate(per 1000 female or male adults) of Hong Kong in 1971 to that in 1973?
Provide a succinct answer. 1.05. What is the ratio of the Mortality Rate(per 1000 female or male adults) of Cuba in 1971 to that in 1974?
Make the answer very short. 1.05. What is the ratio of the Mortality Rate(per 1000 female or male adults) of Equatorial Guinea in 1971 to that in 1974?
Your answer should be compact. 1.02. What is the ratio of the Mortality Rate(per 1000 female or male adults) in Hong Kong in 1971 to that in 1974?
Ensure brevity in your answer.  1.08. What is the ratio of the Mortality Rate(per 1000 female or male adults) in Cuba in 1972 to that in 1973?
Give a very brief answer. 1.01. What is the ratio of the Mortality Rate(per 1000 female or male adults) in Hong Kong in 1972 to that in 1973?
Your response must be concise. 1.02. What is the ratio of the Mortality Rate(per 1000 female or male adults) of Cuba in 1972 to that in 1974?
Offer a terse response. 1.02. What is the ratio of the Mortality Rate(per 1000 female or male adults) in Equatorial Guinea in 1972 to that in 1974?
Make the answer very short. 1.02. What is the ratio of the Mortality Rate(per 1000 female or male adults) in Hong Kong in 1972 to that in 1974?
Offer a terse response. 1.05. What is the ratio of the Mortality Rate(per 1000 female or male adults) of Cuba in 1973 to that in 1974?
Make the answer very short. 1.01. What is the ratio of the Mortality Rate(per 1000 female or male adults) of Hong Kong in 1973 to that in 1974?
Provide a short and direct response. 1.03. What is the difference between the highest and the second highest Mortality Rate(per 1000 female or male adults) in Cuba?
Provide a succinct answer. 3.49. What is the difference between the highest and the second highest Mortality Rate(per 1000 female or male adults) of Equatorial Guinea?
Your answer should be very brief. 3.33. What is the difference between the highest and the second highest Mortality Rate(per 1000 female or male adults) in Hong Kong?
Your answer should be compact. 2.75. What is the difference between the highest and the lowest Mortality Rate(per 1000 female or male adults) in Cuba?
Provide a succinct answer. 19.94. What is the difference between the highest and the lowest Mortality Rate(per 1000 female or male adults) in Equatorial Guinea?
Your answer should be very brief. 23.31. What is the difference between the highest and the lowest Mortality Rate(per 1000 female or male adults) of Hong Kong?
Provide a succinct answer. 18.6. 